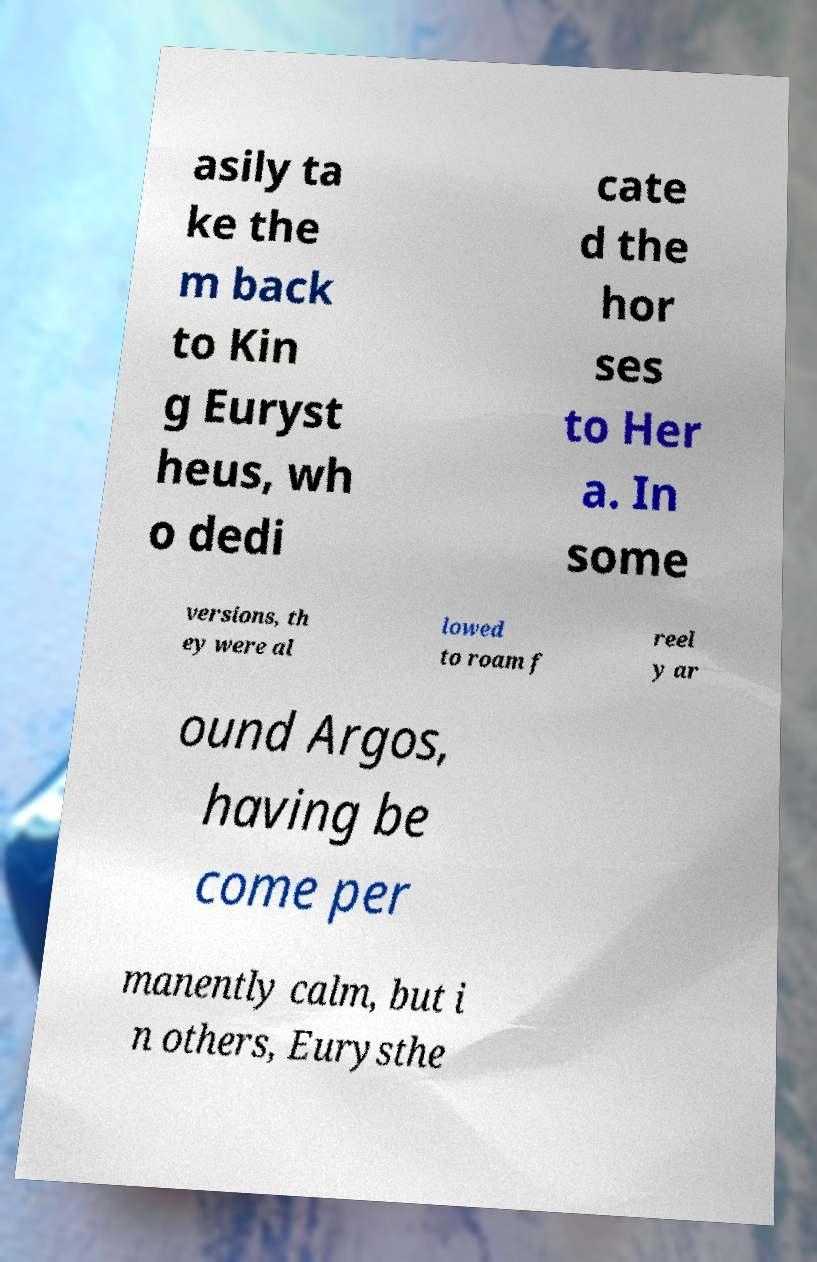For documentation purposes, I need the text within this image transcribed. Could you provide that? asily ta ke the m back to Kin g Euryst heus, wh o dedi cate d the hor ses to Her a. In some versions, th ey were al lowed to roam f reel y ar ound Argos, having be come per manently calm, but i n others, Eurysthe 